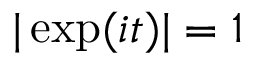<formula> <loc_0><loc_0><loc_500><loc_500>| \exp ( i t ) | = 1</formula> 